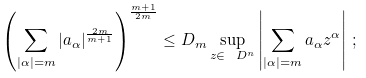Convert formula to latex. <formula><loc_0><loc_0><loc_500><loc_500>\left ( \sum _ { | \alpha | = m } | a _ { \alpha } | ^ { \frac { 2 m } { m + 1 } } \right ) ^ { \frac { m + 1 } { 2 m } } \leq D _ { m } \sup _ { z \in \ D ^ { n } } \left | \sum _ { | \alpha | = m } a _ { \alpha } z ^ { \alpha } \right | \, ;</formula> 